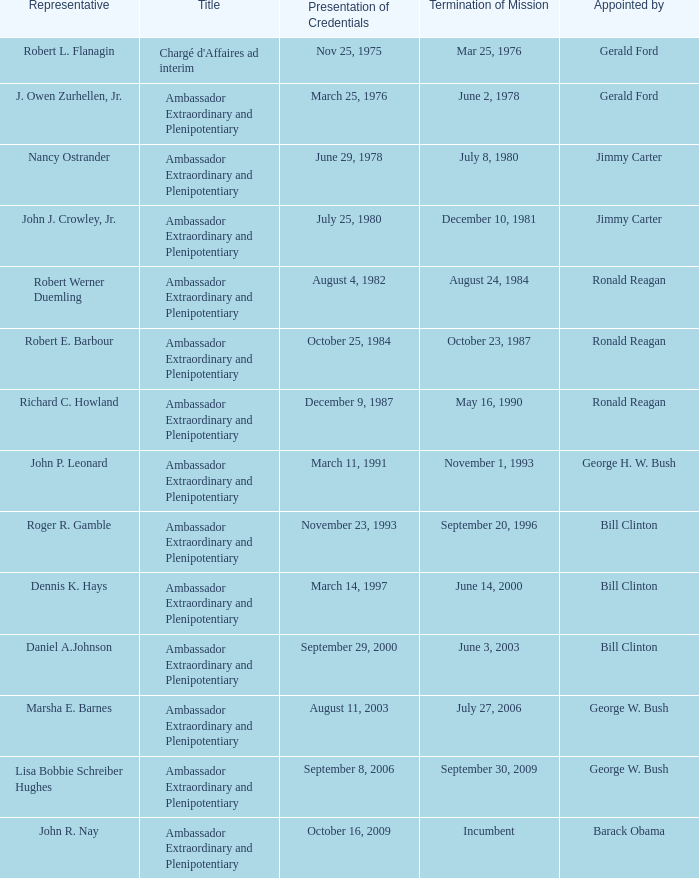What was the mission termination date for the envoy designated by barack obama? Incumbent. 